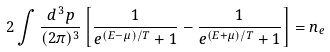Convert formula to latex. <formula><loc_0><loc_0><loc_500><loc_500>2 \int \frac { d ^ { \, 3 } p } { ( 2 \pi ) ^ { 3 } } \left [ \frac { 1 } { e ^ { ( E - \mu ) / T } + 1 } - \frac { 1 } { e ^ { ( E + \mu ) / T } + 1 } \right ] = n _ { e }</formula> 